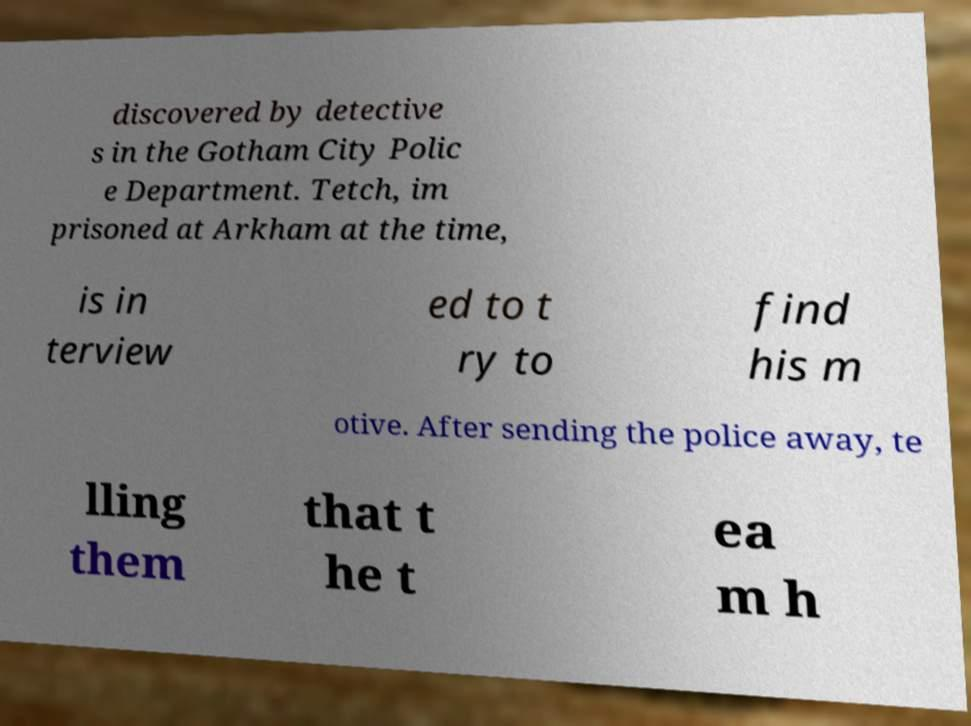I need the written content from this picture converted into text. Can you do that? discovered by detective s in the Gotham City Polic e Department. Tetch, im prisoned at Arkham at the time, is in terview ed to t ry to find his m otive. After sending the police away, te lling them that t he t ea m h 